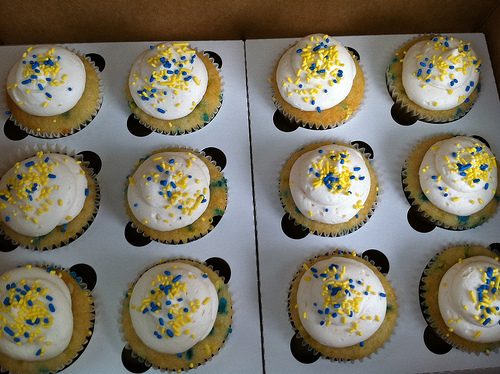<image>
Is there a cake to the left of the cake? No. The cake is not to the left of the cake. From this viewpoint, they have a different horizontal relationship. 